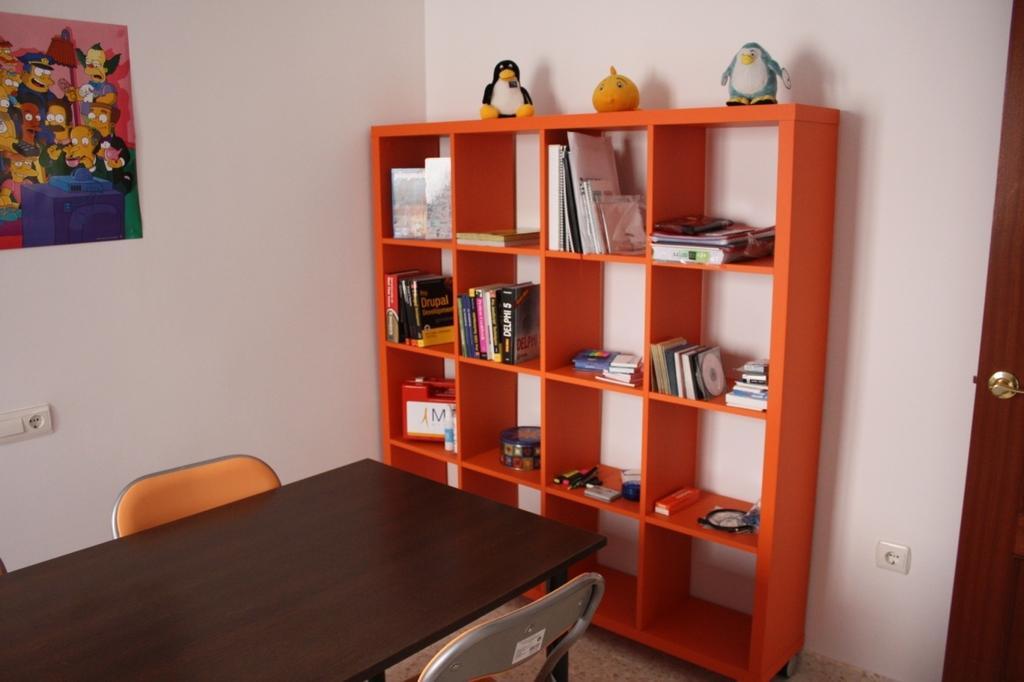Please provide a concise description of this image. In the picture we can see a table two chairs. And to the wall there is a rack which is orange in color, in the racks we can see books and top of it there are three dolls placed and we can also see a picture on the wall, just beside to it we can see a door. 